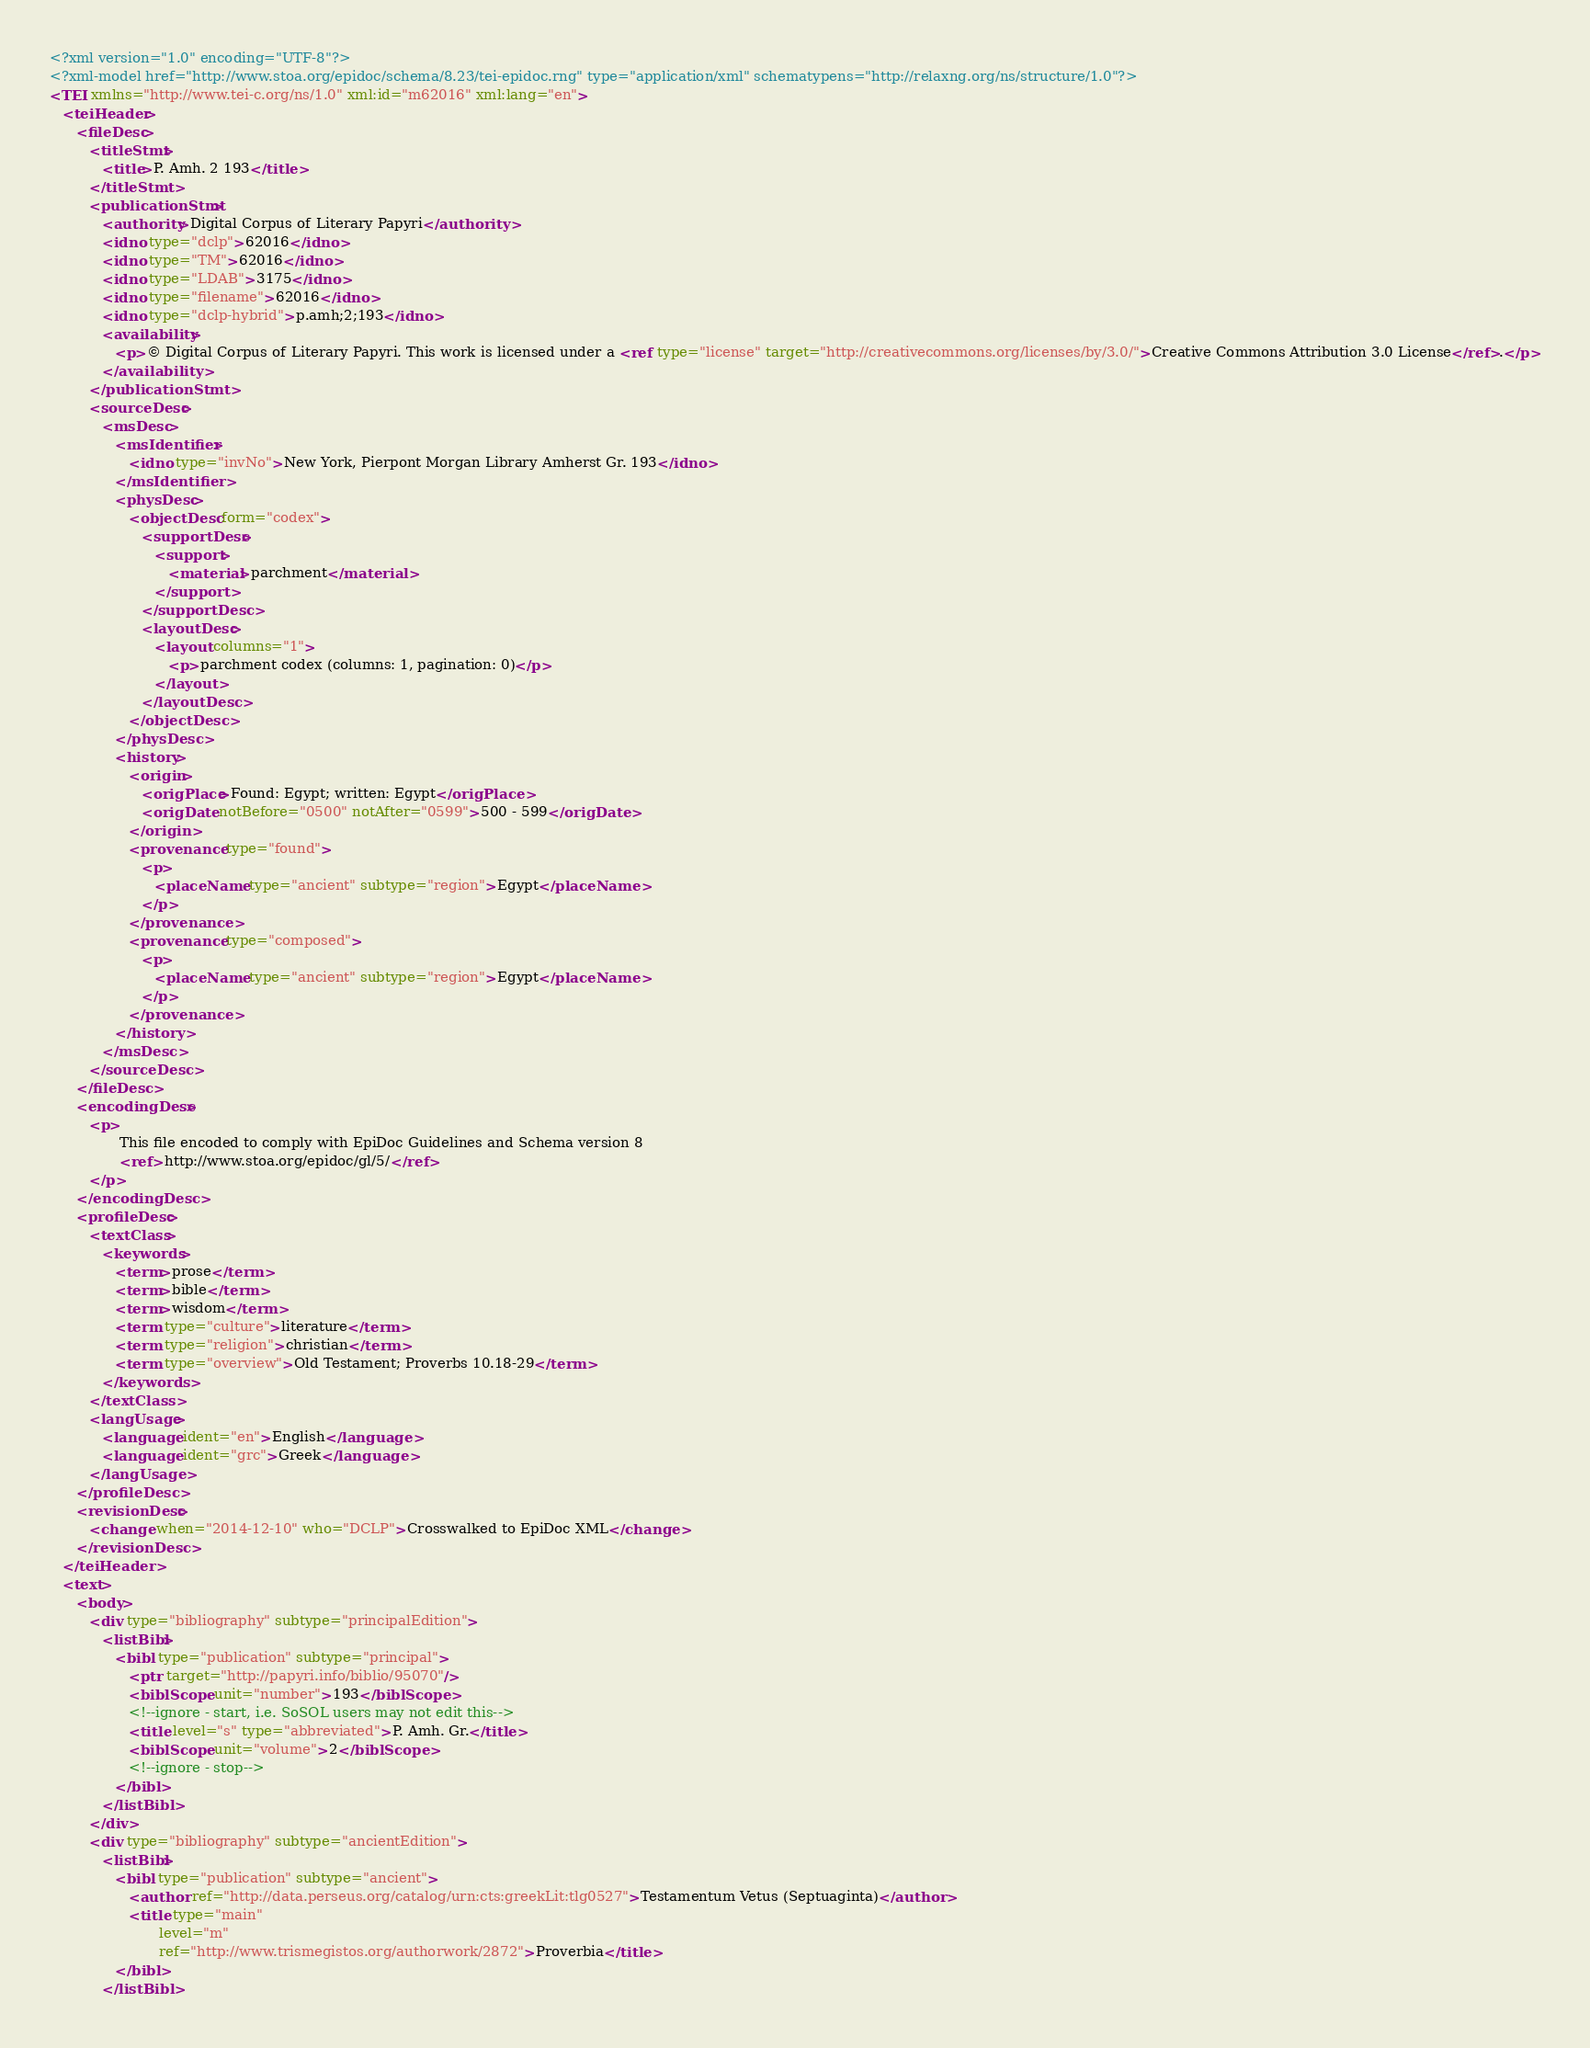Convert code to text. <code><loc_0><loc_0><loc_500><loc_500><_XML_><?xml version="1.0" encoding="UTF-8"?>
<?xml-model href="http://www.stoa.org/epidoc/schema/8.23/tei-epidoc.rng" type="application/xml" schematypens="http://relaxng.org/ns/structure/1.0"?>
<TEI xmlns="http://www.tei-c.org/ns/1.0" xml:id="m62016" xml:lang="en">
   <teiHeader>
      <fileDesc>
         <titleStmt>
            <title>P. Amh. 2 193</title>
         </titleStmt>
         <publicationStmt>
            <authority>Digital Corpus of Literary Papyri</authority>
            <idno type="dclp">62016</idno>
            <idno type="TM">62016</idno>
            <idno type="LDAB">3175</idno>
            <idno type="filename">62016</idno>
            <idno type="dclp-hybrid">p.amh;2;193</idno>
            <availability>
               <p>© Digital Corpus of Literary Papyri. This work is licensed under a <ref type="license" target="http://creativecommons.org/licenses/by/3.0/">Creative Commons Attribution 3.0 License</ref>.</p>
            </availability>
         </publicationStmt>
         <sourceDesc>
            <msDesc>
               <msIdentifier>
                  <idno type="invNo">New York, Pierpont Morgan Library Amherst Gr. 193</idno>
               </msIdentifier>
               <physDesc>
                  <objectDesc form="codex">
                     <supportDesc>
                        <support>
                           <material>parchment</material>
                        </support>
                     </supportDesc>
                     <layoutDesc>
                        <layout columns="1">
                           <p>parchment codex (columns: 1, pagination: 0)</p>
                        </layout>
                     </layoutDesc>
                  </objectDesc>
               </physDesc>
               <history>
                  <origin>
                     <origPlace>Found: Egypt; written: Egypt</origPlace>
                     <origDate notBefore="0500" notAfter="0599">500 - 599</origDate>
                  </origin>
                  <provenance type="found">
                     <p>
                        <placeName type="ancient" subtype="region">Egypt</placeName>
                     </p>
                  </provenance>
                  <provenance type="composed">
                     <p>
                        <placeName type="ancient" subtype="region">Egypt</placeName>
                     </p>
                  </provenance>
               </history>
            </msDesc>
         </sourceDesc>
      </fileDesc>
      <encodingDesc>
         <p>
                This file encoded to comply with EpiDoc Guidelines and Schema version 8
                <ref>http://www.stoa.org/epidoc/gl/5/</ref>
         </p>
      </encodingDesc>
      <profileDesc>
         <textClass>
            <keywords>
               <term>prose</term>
               <term>bible</term>
               <term>wisdom</term>
               <term type="culture">literature</term>
               <term type="religion">christian</term>
               <term type="overview">Old Testament; Proverbs 10.18-29</term>
            </keywords>
         </textClass>
         <langUsage>
            <language ident="en">English</language>
            <language ident="grc">Greek</language>
         </langUsage>
      </profileDesc>
      <revisionDesc>
         <change when="2014-12-10" who="DCLP">Crosswalked to EpiDoc XML</change>
      </revisionDesc>
   </teiHeader>
   <text>
      <body>
         <div type="bibliography" subtype="principalEdition">
            <listBibl>
               <bibl type="publication" subtype="principal">
                  <ptr target="http://papyri.info/biblio/95070"/>
                  <biblScope unit="number">193</biblScope>
                  <!--ignore - start, i.e. SoSOL users may not edit this-->
                  <title level="s" type="abbreviated">P. Amh. Gr.</title>
                  <biblScope unit="volume">2</biblScope>
                  <!--ignore - stop-->
               </bibl>
            </listBibl>
         </div>
         <div type="bibliography" subtype="ancientEdition">
            <listBibl>
               <bibl type="publication" subtype="ancient">
                  <author ref="http://data.perseus.org/catalog/urn:cts:greekLit:tlg0527">Testamentum Vetus (Septuaginta)</author>
                  <title type="main"
                         level="m"
                         ref="http://www.trismegistos.org/authorwork/2872">Proverbia</title>
               </bibl>
            </listBibl></code> 